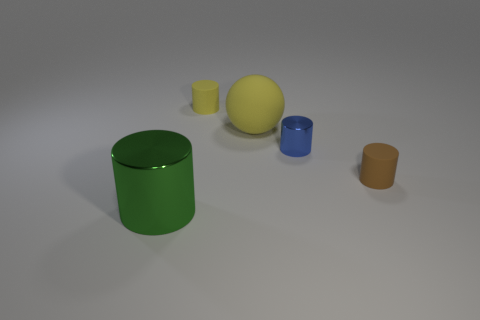Add 3 small brown matte cylinders. How many objects exist? 8 Subtract all large green cylinders. How many cylinders are left? 3 Subtract all yellow cylinders. How many cylinders are left? 3 Subtract all green blocks. How many green cylinders are left? 1 Subtract 0 cyan balls. How many objects are left? 5 Subtract all spheres. How many objects are left? 4 Subtract 2 cylinders. How many cylinders are left? 2 Subtract all yellow cylinders. Subtract all purple cubes. How many cylinders are left? 3 Subtract all large purple cubes. Subtract all rubber objects. How many objects are left? 2 Add 5 yellow rubber spheres. How many yellow rubber spheres are left? 6 